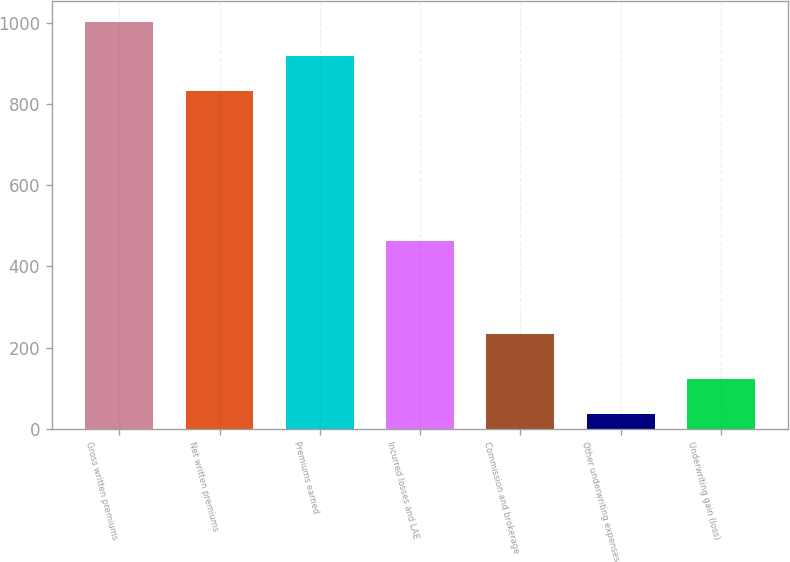<chart> <loc_0><loc_0><loc_500><loc_500><bar_chart><fcel>Gross written premiums<fcel>Net written premiums<fcel>Premiums earned<fcel>Incurred losses and LAE<fcel>Commission and brokerage<fcel>Other underwriting expenses<fcel>Underwriting gain (loss)<nl><fcel>1002.72<fcel>831.9<fcel>917.31<fcel>461.9<fcel>234<fcel>36.3<fcel>121.71<nl></chart> 